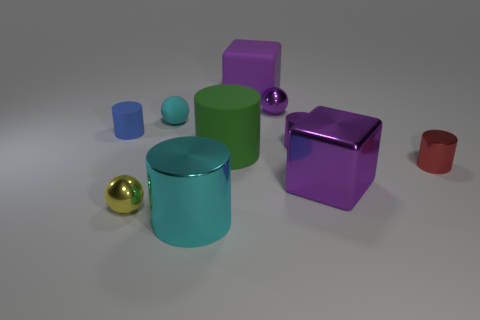Subtract all purple cylinders. How many cylinders are left? 4 Subtract all purple balls. How many balls are left? 2 Subtract 1 blocks. How many blocks are left? 1 Subtract all balls. How many objects are left? 7 Subtract all purple cylinders. Subtract all yellow spheres. How many cylinders are left? 4 Subtract all gray cylinders. How many gray cubes are left? 0 Subtract all tiny metal objects. Subtract all green things. How many objects are left? 5 Add 6 tiny yellow metallic things. How many tiny yellow metallic things are left? 7 Add 9 tiny cubes. How many tiny cubes exist? 9 Subtract 1 yellow balls. How many objects are left? 9 